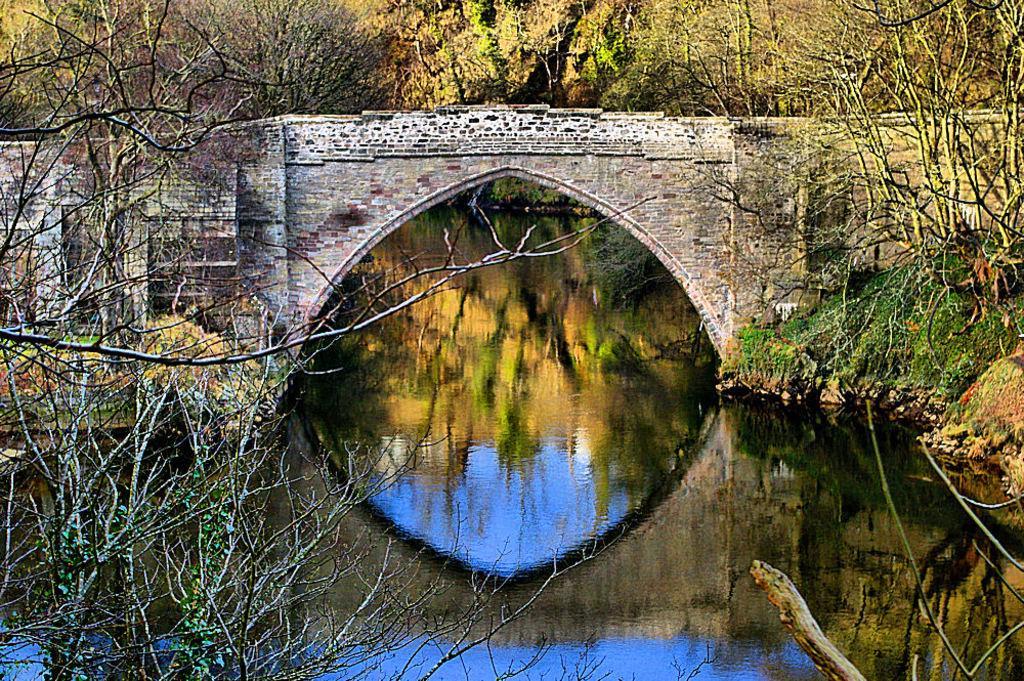Can you describe this image briefly? In this image there are trees towards the top of the image, there are trees towards the right of the image, there are trees towards the left of the image, there is a wall, there is an arch, there is water towards the bottom of the image. 